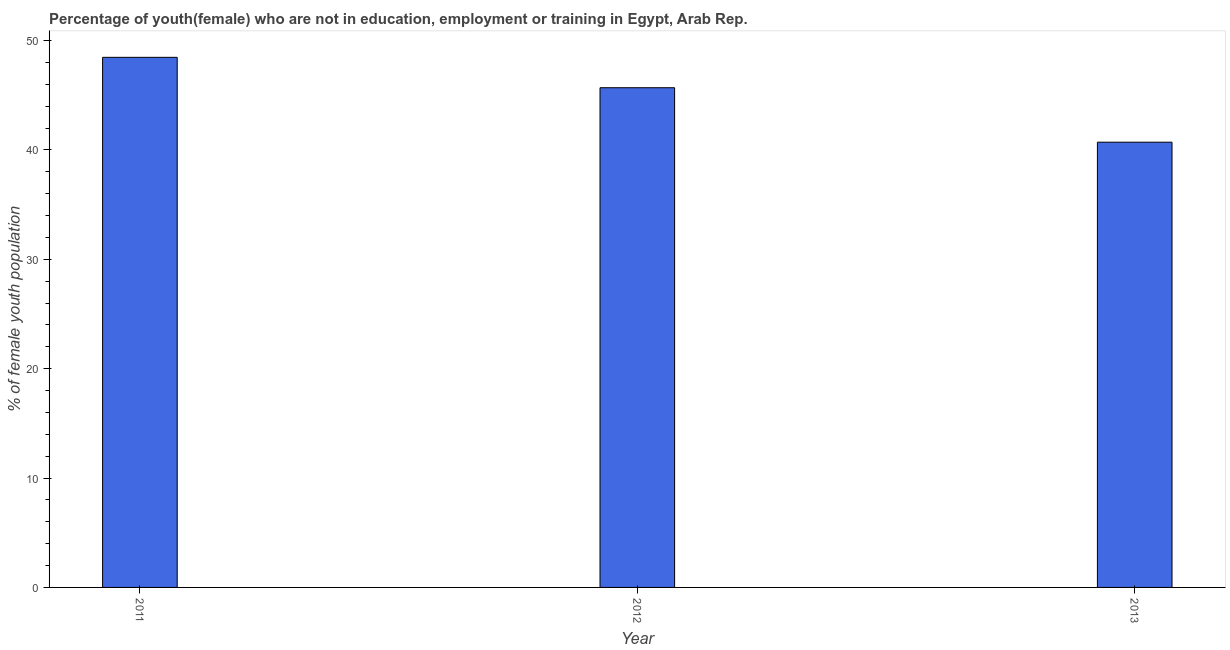What is the title of the graph?
Provide a short and direct response. Percentage of youth(female) who are not in education, employment or training in Egypt, Arab Rep. What is the label or title of the X-axis?
Provide a short and direct response. Year. What is the label or title of the Y-axis?
Offer a terse response. % of female youth population. What is the unemployed female youth population in 2013?
Offer a very short reply. 40.71. Across all years, what is the maximum unemployed female youth population?
Make the answer very short. 48.47. Across all years, what is the minimum unemployed female youth population?
Keep it short and to the point. 40.71. What is the sum of the unemployed female youth population?
Ensure brevity in your answer.  134.87. What is the difference between the unemployed female youth population in 2012 and 2013?
Give a very brief answer. 4.98. What is the average unemployed female youth population per year?
Provide a succinct answer. 44.96. What is the median unemployed female youth population?
Your response must be concise. 45.69. Do a majority of the years between 2011 and 2013 (inclusive) have unemployed female youth population greater than 4 %?
Give a very brief answer. Yes. What is the ratio of the unemployed female youth population in 2011 to that in 2012?
Provide a succinct answer. 1.06. Is the difference between the unemployed female youth population in 2012 and 2013 greater than the difference between any two years?
Make the answer very short. No. What is the difference between the highest and the second highest unemployed female youth population?
Offer a very short reply. 2.78. What is the difference between the highest and the lowest unemployed female youth population?
Your answer should be compact. 7.76. How many years are there in the graph?
Offer a terse response. 3. What is the difference between two consecutive major ticks on the Y-axis?
Keep it short and to the point. 10. What is the % of female youth population in 2011?
Provide a short and direct response. 48.47. What is the % of female youth population of 2012?
Offer a very short reply. 45.69. What is the % of female youth population in 2013?
Ensure brevity in your answer.  40.71. What is the difference between the % of female youth population in 2011 and 2012?
Offer a very short reply. 2.78. What is the difference between the % of female youth population in 2011 and 2013?
Offer a terse response. 7.76. What is the difference between the % of female youth population in 2012 and 2013?
Offer a very short reply. 4.98. What is the ratio of the % of female youth population in 2011 to that in 2012?
Make the answer very short. 1.06. What is the ratio of the % of female youth population in 2011 to that in 2013?
Provide a short and direct response. 1.19. What is the ratio of the % of female youth population in 2012 to that in 2013?
Provide a succinct answer. 1.12. 